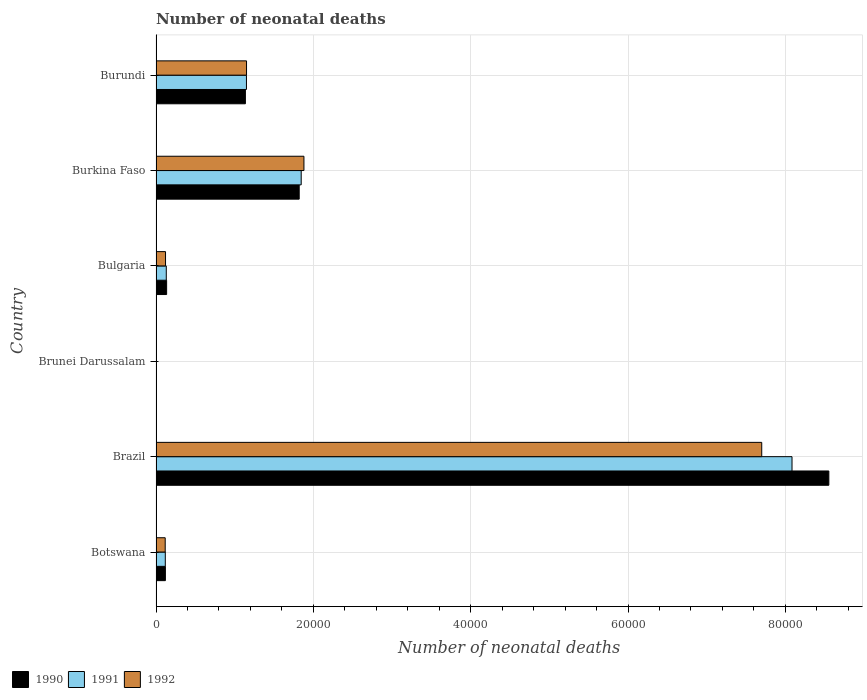Are the number of bars on each tick of the Y-axis equal?
Your answer should be compact. Yes. What is the label of the 3rd group of bars from the top?
Provide a short and direct response. Bulgaria. In how many cases, is the number of bars for a given country not equal to the number of legend labels?
Provide a succinct answer. 0. What is the number of neonatal deaths in in 1992 in Botswana?
Ensure brevity in your answer.  1167. Across all countries, what is the maximum number of neonatal deaths in in 1992?
Offer a terse response. 7.70e+04. Across all countries, what is the minimum number of neonatal deaths in in 1991?
Offer a terse response. 46. In which country was the number of neonatal deaths in in 1990 maximum?
Provide a short and direct response. Brazil. In which country was the number of neonatal deaths in in 1991 minimum?
Make the answer very short. Brunei Darussalam. What is the total number of neonatal deaths in in 1992 in the graph?
Ensure brevity in your answer.  1.10e+05. What is the difference between the number of neonatal deaths in in 1991 in Burkina Faso and that in Burundi?
Give a very brief answer. 6960. What is the difference between the number of neonatal deaths in in 1992 in Brazil and the number of neonatal deaths in in 1991 in Botswana?
Your answer should be very brief. 7.58e+04. What is the average number of neonatal deaths in in 1992 per country?
Ensure brevity in your answer.  1.83e+04. What is the difference between the number of neonatal deaths in in 1992 and number of neonatal deaths in in 1991 in Burundi?
Make the answer very short. 11. What is the ratio of the number of neonatal deaths in in 1992 in Brazil to that in Bulgaria?
Keep it short and to the point. 63.74. Is the difference between the number of neonatal deaths in in 1992 in Brunei Darussalam and Burkina Faso greater than the difference between the number of neonatal deaths in in 1991 in Brunei Darussalam and Burkina Faso?
Offer a terse response. No. What is the difference between the highest and the second highest number of neonatal deaths in in 1991?
Keep it short and to the point. 6.24e+04. What is the difference between the highest and the lowest number of neonatal deaths in in 1991?
Keep it short and to the point. 8.08e+04. In how many countries, is the number of neonatal deaths in in 1990 greater than the average number of neonatal deaths in in 1990 taken over all countries?
Offer a very short reply. 1. What does the 3rd bar from the top in Brazil represents?
Give a very brief answer. 1990. What does the 1st bar from the bottom in Brunei Darussalam represents?
Your response must be concise. 1990. How many bars are there?
Your response must be concise. 18. Are all the bars in the graph horizontal?
Offer a terse response. Yes. What is the difference between two consecutive major ticks on the X-axis?
Provide a short and direct response. 2.00e+04. Are the values on the major ticks of X-axis written in scientific E-notation?
Provide a short and direct response. No. How many legend labels are there?
Keep it short and to the point. 3. How are the legend labels stacked?
Your response must be concise. Horizontal. What is the title of the graph?
Your answer should be compact. Number of neonatal deaths. What is the label or title of the X-axis?
Offer a terse response. Number of neonatal deaths. What is the Number of neonatal deaths in 1990 in Botswana?
Your answer should be very brief. 1191. What is the Number of neonatal deaths of 1991 in Botswana?
Provide a succinct answer. 1180. What is the Number of neonatal deaths of 1992 in Botswana?
Give a very brief answer. 1167. What is the Number of neonatal deaths in 1990 in Brazil?
Make the answer very short. 8.55e+04. What is the Number of neonatal deaths in 1991 in Brazil?
Your answer should be very brief. 8.09e+04. What is the Number of neonatal deaths in 1992 in Brazil?
Offer a terse response. 7.70e+04. What is the Number of neonatal deaths in 1990 in Brunei Darussalam?
Make the answer very short. 46. What is the Number of neonatal deaths in 1990 in Bulgaria?
Provide a short and direct response. 1348. What is the Number of neonatal deaths in 1991 in Bulgaria?
Provide a short and direct response. 1305. What is the Number of neonatal deaths in 1992 in Bulgaria?
Offer a terse response. 1208. What is the Number of neonatal deaths of 1990 in Burkina Faso?
Offer a terse response. 1.82e+04. What is the Number of neonatal deaths in 1991 in Burkina Faso?
Give a very brief answer. 1.85e+04. What is the Number of neonatal deaths in 1992 in Burkina Faso?
Offer a terse response. 1.88e+04. What is the Number of neonatal deaths in 1990 in Burundi?
Your answer should be very brief. 1.14e+04. What is the Number of neonatal deaths in 1991 in Burundi?
Give a very brief answer. 1.15e+04. What is the Number of neonatal deaths of 1992 in Burundi?
Make the answer very short. 1.15e+04. Across all countries, what is the maximum Number of neonatal deaths of 1990?
Provide a succinct answer. 8.55e+04. Across all countries, what is the maximum Number of neonatal deaths in 1991?
Your answer should be very brief. 8.09e+04. Across all countries, what is the maximum Number of neonatal deaths in 1992?
Give a very brief answer. 7.70e+04. Across all countries, what is the minimum Number of neonatal deaths in 1990?
Give a very brief answer. 46. Across all countries, what is the minimum Number of neonatal deaths in 1991?
Offer a very short reply. 46. Across all countries, what is the minimum Number of neonatal deaths of 1992?
Keep it short and to the point. 45. What is the total Number of neonatal deaths of 1990 in the graph?
Provide a short and direct response. 1.18e+05. What is the total Number of neonatal deaths of 1991 in the graph?
Make the answer very short. 1.13e+05. What is the total Number of neonatal deaths in 1992 in the graph?
Offer a terse response. 1.10e+05. What is the difference between the Number of neonatal deaths of 1990 in Botswana and that in Brazil?
Offer a very short reply. -8.43e+04. What is the difference between the Number of neonatal deaths of 1991 in Botswana and that in Brazil?
Offer a very short reply. -7.97e+04. What is the difference between the Number of neonatal deaths in 1992 in Botswana and that in Brazil?
Ensure brevity in your answer.  -7.58e+04. What is the difference between the Number of neonatal deaths of 1990 in Botswana and that in Brunei Darussalam?
Give a very brief answer. 1145. What is the difference between the Number of neonatal deaths in 1991 in Botswana and that in Brunei Darussalam?
Provide a short and direct response. 1134. What is the difference between the Number of neonatal deaths in 1992 in Botswana and that in Brunei Darussalam?
Offer a very short reply. 1122. What is the difference between the Number of neonatal deaths in 1990 in Botswana and that in Bulgaria?
Provide a succinct answer. -157. What is the difference between the Number of neonatal deaths in 1991 in Botswana and that in Bulgaria?
Provide a short and direct response. -125. What is the difference between the Number of neonatal deaths of 1992 in Botswana and that in Bulgaria?
Offer a terse response. -41. What is the difference between the Number of neonatal deaths of 1990 in Botswana and that in Burkina Faso?
Offer a terse response. -1.70e+04. What is the difference between the Number of neonatal deaths in 1991 in Botswana and that in Burkina Faso?
Keep it short and to the point. -1.73e+04. What is the difference between the Number of neonatal deaths of 1992 in Botswana and that in Burkina Faso?
Provide a succinct answer. -1.76e+04. What is the difference between the Number of neonatal deaths in 1990 in Botswana and that in Burundi?
Your answer should be compact. -1.02e+04. What is the difference between the Number of neonatal deaths in 1991 in Botswana and that in Burundi?
Your answer should be compact. -1.03e+04. What is the difference between the Number of neonatal deaths in 1992 in Botswana and that in Burundi?
Offer a terse response. -1.03e+04. What is the difference between the Number of neonatal deaths of 1990 in Brazil and that in Brunei Darussalam?
Make the answer very short. 8.55e+04. What is the difference between the Number of neonatal deaths of 1991 in Brazil and that in Brunei Darussalam?
Ensure brevity in your answer.  8.08e+04. What is the difference between the Number of neonatal deaths of 1992 in Brazil and that in Brunei Darussalam?
Offer a very short reply. 7.70e+04. What is the difference between the Number of neonatal deaths in 1990 in Brazil and that in Bulgaria?
Your response must be concise. 8.42e+04. What is the difference between the Number of neonatal deaths in 1991 in Brazil and that in Bulgaria?
Make the answer very short. 7.95e+04. What is the difference between the Number of neonatal deaths of 1992 in Brazil and that in Bulgaria?
Offer a terse response. 7.58e+04. What is the difference between the Number of neonatal deaths in 1990 in Brazil and that in Burkina Faso?
Keep it short and to the point. 6.73e+04. What is the difference between the Number of neonatal deaths of 1991 in Brazil and that in Burkina Faso?
Your answer should be compact. 6.24e+04. What is the difference between the Number of neonatal deaths of 1992 in Brazil and that in Burkina Faso?
Your response must be concise. 5.82e+04. What is the difference between the Number of neonatal deaths of 1990 in Brazil and that in Burundi?
Your answer should be compact. 7.42e+04. What is the difference between the Number of neonatal deaths of 1991 in Brazil and that in Burundi?
Your answer should be compact. 6.94e+04. What is the difference between the Number of neonatal deaths in 1992 in Brazil and that in Burundi?
Make the answer very short. 6.55e+04. What is the difference between the Number of neonatal deaths of 1990 in Brunei Darussalam and that in Bulgaria?
Your answer should be very brief. -1302. What is the difference between the Number of neonatal deaths of 1991 in Brunei Darussalam and that in Bulgaria?
Give a very brief answer. -1259. What is the difference between the Number of neonatal deaths of 1992 in Brunei Darussalam and that in Bulgaria?
Ensure brevity in your answer.  -1163. What is the difference between the Number of neonatal deaths in 1990 in Brunei Darussalam and that in Burkina Faso?
Your answer should be compact. -1.82e+04. What is the difference between the Number of neonatal deaths in 1991 in Brunei Darussalam and that in Burkina Faso?
Your response must be concise. -1.84e+04. What is the difference between the Number of neonatal deaths of 1992 in Brunei Darussalam and that in Burkina Faso?
Keep it short and to the point. -1.88e+04. What is the difference between the Number of neonatal deaths of 1990 in Brunei Darussalam and that in Burundi?
Your response must be concise. -1.13e+04. What is the difference between the Number of neonatal deaths of 1991 in Brunei Darussalam and that in Burundi?
Keep it short and to the point. -1.14e+04. What is the difference between the Number of neonatal deaths in 1992 in Brunei Darussalam and that in Burundi?
Keep it short and to the point. -1.15e+04. What is the difference between the Number of neonatal deaths in 1990 in Bulgaria and that in Burkina Faso?
Provide a succinct answer. -1.69e+04. What is the difference between the Number of neonatal deaths in 1991 in Bulgaria and that in Burkina Faso?
Provide a short and direct response. -1.72e+04. What is the difference between the Number of neonatal deaths of 1992 in Bulgaria and that in Burkina Faso?
Provide a succinct answer. -1.76e+04. What is the difference between the Number of neonatal deaths of 1990 in Bulgaria and that in Burundi?
Offer a very short reply. -1.00e+04. What is the difference between the Number of neonatal deaths of 1991 in Bulgaria and that in Burundi?
Your answer should be compact. -1.02e+04. What is the difference between the Number of neonatal deaths in 1992 in Bulgaria and that in Burundi?
Provide a succinct answer. -1.03e+04. What is the difference between the Number of neonatal deaths of 1990 in Burkina Faso and that in Burundi?
Your response must be concise. 6839. What is the difference between the Number of neonatal deaths in 1991 in Burkina Faso and that in Burundi?
Keep it short and to the point. 6960. What is the difference between the Number of neonatal deaths in 1992 in Burkina Faso and that in Burundi?
Offer a very short reply. 7296. What is the difference between the Number of neonatal deaths in 1990 in Botswana and the Number of neonatal deaths in 1991 in Brazil?
Give a very brief answer. -7.97e+04. What is the difference between the Number of neonatal deaths of 1990 in Botswana and the Number of neonatal deaths of 1992 in Brazil?
Give a very brief answer. -7.58e+04. What is the difference between the Number of neonatal deaths in 1991 in Botswana and the Number of neonatal deaths in 1992 in Brazil?
Offer a very short reply. -7.58e+04. What is the difference between the Number of neonatal deaths of 1990 in Botswana and the Number of neonatal deaths of 1991 in Brunei Darussalam?
Offer a terse response. 1145. What is the difference between the Number of neonatal deaths of 1990 in Botswana and the Number of neonatal deaths of 1992 in Brunei Darussalam?
Your answer should be very brief. 1146. What is the difference between the Number of neonatal deaths of 1991 in Botswana and the Number of neonatal deaths of 1992 in Brunei Darussalam?
Ensure brevity in your answer.  1135. What is the difference between the Number of neonatal deaths of 1990 in Botswana and the Number of neonatal deaths of 1991 in Bulgaria?
Offer a very short reply. -114. What is the difference between the Number of neonatal deaths of 1990 in Botswana and the Number of neonatal deaths of 1992 in Bulgaria?
Offer a very short reply. -17. What is the difference between the Number of neonatal deaths in 1991 in Botswana and the Number of neonatal deaths in 1992 in Bulgaria?
Provide a succinct answer. -28. What is the difference between the Number of neonatal deaths in 1990 in Botswana and the Number of neonatal deaths in 1991 in Burkina Faso?
Offer a terse response. -1.73e+04. What is the difference between the Number of neonatal deaths of 1990 in Botswana and the Number of neonatal deaths of 1992 in Burkina Faso?
Make the answer very short. -1.76e+04. What is the difference between the Number of neonatal deaths of 1991 in Botswana and the Number of neonatal deaths of 1992 in Burkina Faso?
Your answer should be compact. -1.76e+04. What is the difference between the Number of neonatal deaths in 1990 in Botswana and the Number of neonatal deaths in 1991 in Burundi?
Give a very brief answer. -1.03e+04. What is the difference between the Number of neonatal deaths in 1990 in Botswana and the Number of neonatal deaths in 1992 in Burundi?
Your answer should be very brief. -1.03e+04. What is the difference between the Number of neonatal deaths of 1991 in Botswana and the Number of neonatal deaths of 1992 in Burundi?
Give a very brief answer. -1.03e+04. What is the difference between the Number of neonatal deaths in 1990 in Brazil and the Number of neonatal deaths in 1991 in Brunei Darussalam?
Offer a terse response. 8.55e+04. What is the difference between the Number of neonatal deaths of 1990 in Brazil and the Number of neonatal deaths of 1992 in Brunei Darussalam?
Make the answer very short. 8.55e+04. What is the difference between the Number of neonatal deaths of 1991 in Brazil and the Number of neonatal deaths of 1992 in Brunei Darussalam?
Give a very brief answer. 8.08e+04. What is the difference between the Number of neonatal deaths of 1990 in Brazil and the Number of neonatal deaths of 1991 in Bulgaria?
Offer a terse response. 8.42e+04. What is the difference between the Number of neonatal deaths in 1990 in Brazil and the Number of neonatal deaths in 1992 in Bulgaria?
Ensure brevity in your answer.  8.43e+04. What is the difference between the Number of neonatal deaths of 1991 in Brazil and the Number of neonatal deaths of 1992 in Bulgaria?
Your answer should be compact. 7.96e+04. What is the difference between the Number of neonatal deaths of 1990 in Brazil and the Number of neonatal deaths of 1991 in Burkina Faso?
Your answer should be very brief. 6.71e+04. What is the difference between the Number of neonatal deaths of 1990 in Brazil and the Number of neonatal deaths of 1992 in Burkina Faso?
Your answer should be very brief. 6.67e+04. What is the difference between the Number of neonatal deaths in 1991 in Brazil and the Number of neonatal deaths in 1992 in Burkina Faso?
Your answer should be compact. 6.20e+04. What is the difference between the Number of neonatal deaths in 1990 in Brazil and the Number of neonatal deaths in 1991 in Burundi?
Keep it short and to the point. 7.40e+04. What is the difference between the Number of neonatal deaths in 1990 in Brazil and the Number of neonatal deaths in 1992 in Burundi?
Keep it short and to the point. 7.40e+04. What is the difference between the Number of neonatal deaths of 1991 in Brazil and the Number of neonatal deaths of 1992 in Burundi?
Keep it short and to the point. 6.93e+04. What is the difference between the Number of neonatal deaths of 1990 in Brunei Darussalam and the Number of neonatal deaths of 1991 in Bulgaria?
Ensure brevity in your answer.  -1259. What is the difference between the Number of neonatal deaths in 1990 in Brunei Darussalam and the Number of neonatal deaths in 1992 in Bulgaria?
Provide a succinct answer. -1162. What is the difference between the Number of neonatal deaths in 1991 in Brunei Darussalam and the Number of neonatal deaths in 1992 in Bulgaria?
Your response must be concise. -1162. What is the difference between the Number of neonatal deaths of 1990 in Brunei Darussalam and the Number of neonatal deaths of 1991 in Burkina Faso?
Provide a succinct answer. -1.84e+04. What is the difference between the Number of neonatal deaths in 1990 in Brunei Darussalam and the Number of neonatal deaths in 1992 in Burkina Faso?
Give a very brief answer. -1.88e+04. What is the difference between the Number of neonatal deaths of 1991 in Brunei Darussalam and the Number of neonatal deaths of 1992 in Burkina Faso?
Offer a very short reply. -1.88e+04. What is the difference between the Number of neonatal deaths in 1990 in Brunei Darussalam and the Number of neonatal deaths in 1991 in Burundi?
Give a very brief answer. -1.14e+04. What is the difference between the Number of neonatal deaths in 1990 in Brunei Darussalam and the Number of neonatal deaths in 1992 in Burundi?
Provide a short and direct response. -1.15e+04. What is the difference between the Number of neonatal deaths in 1991 in Brunei Darussalam and the Number of neonatal deaths in 1992 in Burundi?
Your response must be concise. -1.15e+04. What is the difference between the Number of neonatal deaths in 1990 in Bulgaria and the Number of neonatal deaths in 1991 in Burkina Faso?
Provide a short and direct response. -1.71e+04. What is the difference between the Number of neonatal deaths in 1990 in Bulgaria and the Number of neonatal deaths in 1992 in Burkina Faso?
Give a very brief answer. -1.75e+04. What is the difference between the Number of neonatal deaths of 1991 in Bulgaria and the Number of neonatal deaths of 1992 in Burkina Faso?
Keep it short and to the point. -1.75e+04. What is the difference between the Number of neonatal deaths in 1990 in Bulgaria and the Number of neonatal deaths in 1991 in Burundi?
Provide a succinct answer. -1.01e+04. What is the difference between the Number of neonatal deaths of 1990 in Bulgaria and the Number of neonatal deaths of 1992 in Burundi?
Ensure brevity in your answer.  -1.02e+04. What is the difference between the Number of neonatal deaths of 1991 in Bulgaria and the Number of neonatal deaths of 1992 in Burundi?
Provide a short and direct response. -1.02e+04. What is the difference between the Number of neonatal deaths in 1990 in Burkina Faso and the Number of neonatal deaths in 1991 in Burundi?
Ensure brevity in your answer.  6705. What is the difference between the Number of neonatal deaths of 1990 in Burkina Faso and the Number of neonatal deaths of 1992 in Burundi?
Ensure brevity in your answer.  6694. What is the difference between the Number of neonatal deaths of 1991 in Burkina Faso and the Number of neonatal deaths of 1992 in Burundi?
Your response must be concise. 6949. What is the average Number of neonatal deaths of 1990 per country?
Make the answer very short. 1.96e+04. What is the average Number of neonatal deaths of 1991 per country?
Make the answer very short. 1.89e+04. What is the average Number of neonatal deaths of 1992 per country?
Offer a very short reply. 1.83e+04. What is the difference between the Number of neonatal deaths in 1990 and Number of neonatal deaths in 1991 in Botswana?
Ensure brevity in your answer.  11. What is the difference between the Number of neonatal deaths of 1990 and Number of neonatal deaths of 1992 in Botswana?
Your response must be concise. 24. What is the difference between the Number of neonatal deaths in 1990 and Number of neonatal deaths in 1991 in Brazil?
Keep it short and to the point. 4682. What is the difference between the Number of neonatal deaths in 1990 and Number of neonatal deaths in 1992 in Brazil?
Offer a very short reply. 8532. What is the difference between the Number of neonatal deaths of 1991 and Number of neonatal deaths of 1992 in Brazil?
Offer a terse response. 3850. What is the difference between the Number of neonatal deaths of 1991 and Number of neonatal deaths of 1992 in Brunei Darussalam?
Provide a succinct answer. 1. What is the difference between the Number of neonatal deaths of 1990 and Number of neonatal deaths of 1992 in Bulgaria?
Offer a very short reply. 140. What is the difference between the Number of neonatal deaths in 1991 and Number of neonatal deaths in 1992 in Bulgaria?
Your response must be concise. 97. What is the difference between the Number of neonatal deaths in 1990 and Number of neonatal deaths in 1991 in Burkina Faso?
Provide a succinct answer. -255. What is the difference between the Number of neonatal deaths in 1990 and Number of neonatal deaths in 1992 in Burkina Faso?
Keep it short and to the point. -602. What is the difference between the Number of neonatal deaths in 1991 and Number of neonatal deaths in 1992 in Burkina Faso?
Offer a terse response. -347. What is the difference between the Number of neonatal deaths in 1990 and Number of neonatal deaths in 1991 in Burundi?
Your answer should be compact. -134. What is the difference between the Number of neonatal deaths of 1990 and Number of neonatal deaths of 1992 in Burundi?
Make the answer very short. -145. What is the ratio of the Number of neonatal deaths of 1990 in Botswana to that in Brazil?
Offer a very short reply. 0.01. What is the ratio of the Number of neonatal deaths in 1991 in Botswana to that in Brazil?
Give a very brief answer. 0.01. What is the ratio of the Number of neonatal deaths in 1992 in Botswana to that in Brazil?
Ensure brevity in your answer.  0.02. What is the ratio of the Number of neonatal deaths of 1990 in Botswana to that in Brunei Darussalam?
Offer a very short reply. 25.89. What is the ratio of the Number of neonatal deaths of 1991 in Botswana to that in Brunei Darussalam?
Ensure brevity in your answer.  25.65. What is the ratio of the Number of neonatal deaths of 1992 in Botswana to that in Brunei Darussalam?
Offer a very short reply. 25.93. What is the ratio of the Number of neonatal deaths in 1990 in Botswana to that in Bulgaria?
Your answer should be compact. 0.88. What is the ratio of the Number of neonatal deaths in 1991 in Botswana to that in Bulgaria?
Provide a succinct answer. 0.9. What is the ratio of the Number of neonatal deaths in 1992 in Botswana to that in Bulgaria?
Offer a terse response. 0.97. What is the ratio of the Number of neonatal deaths of 1990 in Botswana to that in Burkina Faso?
Ensure brevity in your answer.  0.07. What is the ratio of the Number of neonatal deaths in 1991 in Botswana to that in Burkina Faso?
Keep it short and to the point. 0.06. What is the ratio of the Number of neonatal deaths of 1992 in Botswana to that in Burkina Faso?
Provide a short and direct response. 0.06. What is the ratio of the Number of neonatal deaths in 1990 in Botswana to that in Burundi?
Your answer should be compact. 0.1. What is the ratio of the Number of neonatal deaths of 1991 in Botswana to that in Burundi?
Provide a short and direct response. 0.1. What is the ratio of the Number of neonatal deaths of 1992 in Botswana to that in Burundi?
Your response must be concise. 0.1. What is the ratio of the Number of neonatal deaths of 1990 in Brazil to that in Brunei Darussalam?
Ensure brevity in your answer.  1859.43. What is the ratio of the Number of neonatal deaths of 1991 in Brazil to that in Brunei Darussalam?
Offer a very short reply. 1757.65. What is the ratio of the Number of neonatal deaths of 1992 in Brazil to that in Brunei Darussalam?
Your answer should be compact. 1711.16. What is the ratio of the Number of neonatal deaths in 1990 in Brazil to that in Bulgaria?
Make the answer very short. 63.45. What is the ratio of the Number of neonatal deaths of 1991 in Brazil to that in Bulgaria?
Provide a short and direct response. 61.96. What is the ratio of the Number of neonatal deaths in 1992 in Brazil to that in Bulgaria?
Your answer should be very brief. 63.74. What is the ratio of the Number of neonatal deaths of 1990 in Brazil to that in Burkina Faso?
Offer a terse response. 4.7. What is the ratio of the Number of neonatal deaths in 1991 in Brazil to that in Burkina Faso?
Your answer should be compact. 4.38. What is the ratio of the Number of neonatal deaths of 1992 in Brazil to that in Burkina Faso?
Ensure brevity in your answer.  4.1. What is the ratio of the Number of neonatal deaths in 1990 in Brazil to that in Burundi?
Give a very brief answer. 7.53. What is the ratio of the Number of neonatal deaths in 1991 in Brazil to that in Burundi?
Offer a terse response. 7.03. What is the ratio of the Number of neonatal deaths in 1992 in Brazil to that in Burundi?
Provide a succinct answer. 6.69. What is the ratio of the Number of neonatal deaths in 1990 in Brunei Darussalam to that in Bulgaria?
Give a very brief answer. 0.03. What is the ratio of the Number of neonatal deaths in 1991 in Brunei Darussalam to that in Bulgaria?
Make the answer very short. 0.04. What is the ratio of the Number of neonatal deaths in 1992 in Brunei Darussalam to that in Bulgaria?
Offer a very short reply. 0.04. What is the ratio of the Number of neonatal deaths of 1990 in Brunei Darussalam to that in Burkina Faso?
Offer a very short reply. 0. What is the ratio of the Number of neonatal deaths in 1991 in Brunei Darussalam to that in Burkina Faso?
Ensure brevity in your answer.  0. What is the ratio of the Number of neonatal deaths in 1992 in Brunei Darussalam to that in Burkina Faso?
Ensure brevity in your answer.  0. What is the ratio of the Number of neonatal deaths of 1990 in Brunei Darussalam to that in Burundi?
Ensure brevity in your answer.  0. What is the ratio of the Number of neonatal deaths in 1991 in Brunei Darussalam to that in Burundi?
Your answer should be very brief. 0. What is the ratio of the Number of neonatal deaths in 1992 in Brunei Darussalam to that in Burundi?
Provide a succinct answer. 0. What is the ratio of the Number of neonatal deaths in 1990 in Bulgaria to that in Burkina Faso?
Give a very brief answer. 0.07. What is the ratio of the Number of neonatal deaths in 1991 in Bulgaria to that in Burkina Faso?
Your answer should be very brief. 0.07. What is the ratio of the Number of neonatal deaths in 1992 in Bulgaria to that in Burkina Faso?
Your answer should be very brief. 0.06. What is the ratio of the Number of neonatal deaths in 1990 in Bulgaria to that in Burundi?
Offer a very short reply. 0.12. What is the ratio of the Number of neonatal deaths of 1991 in Bulgaria to that in Burundi?
Your answer should be compact. 0.11. What is the ratio of the Number of neonatal deaths in 1992 in Bulgaria to that in Burundi?
Provide a succinct answer. 0.1. What is the ratio of the Number of neonatal deaths in 1990 in Burkina Faso to that in Burundi?
Offer a very short reply. 1.6. What is the ratio of the Number of neonatal deaths of 1991 in Burkina Faso to that in Burundi?
Your answer should be compact. 1.61. What is the ratio of the Number of neonatal deaths in 1992 in Burkina Faso to that in Burundi?
Provide a short and direct response. 1.63. What is the difference between the highest and the second highest Number of neonatal deaths of 1990?
Give a very brief answer. 6.73e+04. What is the difference between the highest and the second highest Number of neonatal deaths in 1991?
Keep it short and to the point. 6.24e+04. What is the difference between the highest and the second highest Number of neonatal deaths of 1992?
Offer a terse response. 5.82e+04. What is the difference between the highest and the lowest Number of neonatal deaths in 1990?
Provide a succinct answer. 8.55e+04. What is the difference between the highest and the lowest Number of neonatal deaths in 1991?
Give a very brief answer. 8.08e+04. What is the difference between the highest and the lowest Number of neonatal deaths in 1992?
Offer a very short reply. 7.70e+04. 